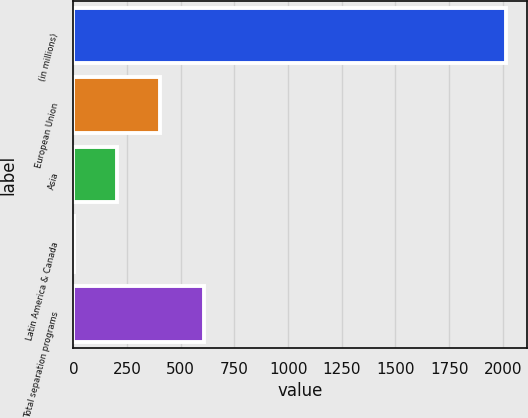<chart> <loc_0><loc_0><loc_500><loc_500><bar_chart><fcel>(in millions)<fcel>European Union<fcel>Asia<fcel>Latin America & Canada<fcel>Total separation programs<nl><fcel>2014<fcel>405.2<fcel>204.1<fcel>3<fcel>606.3<nl></chart> 